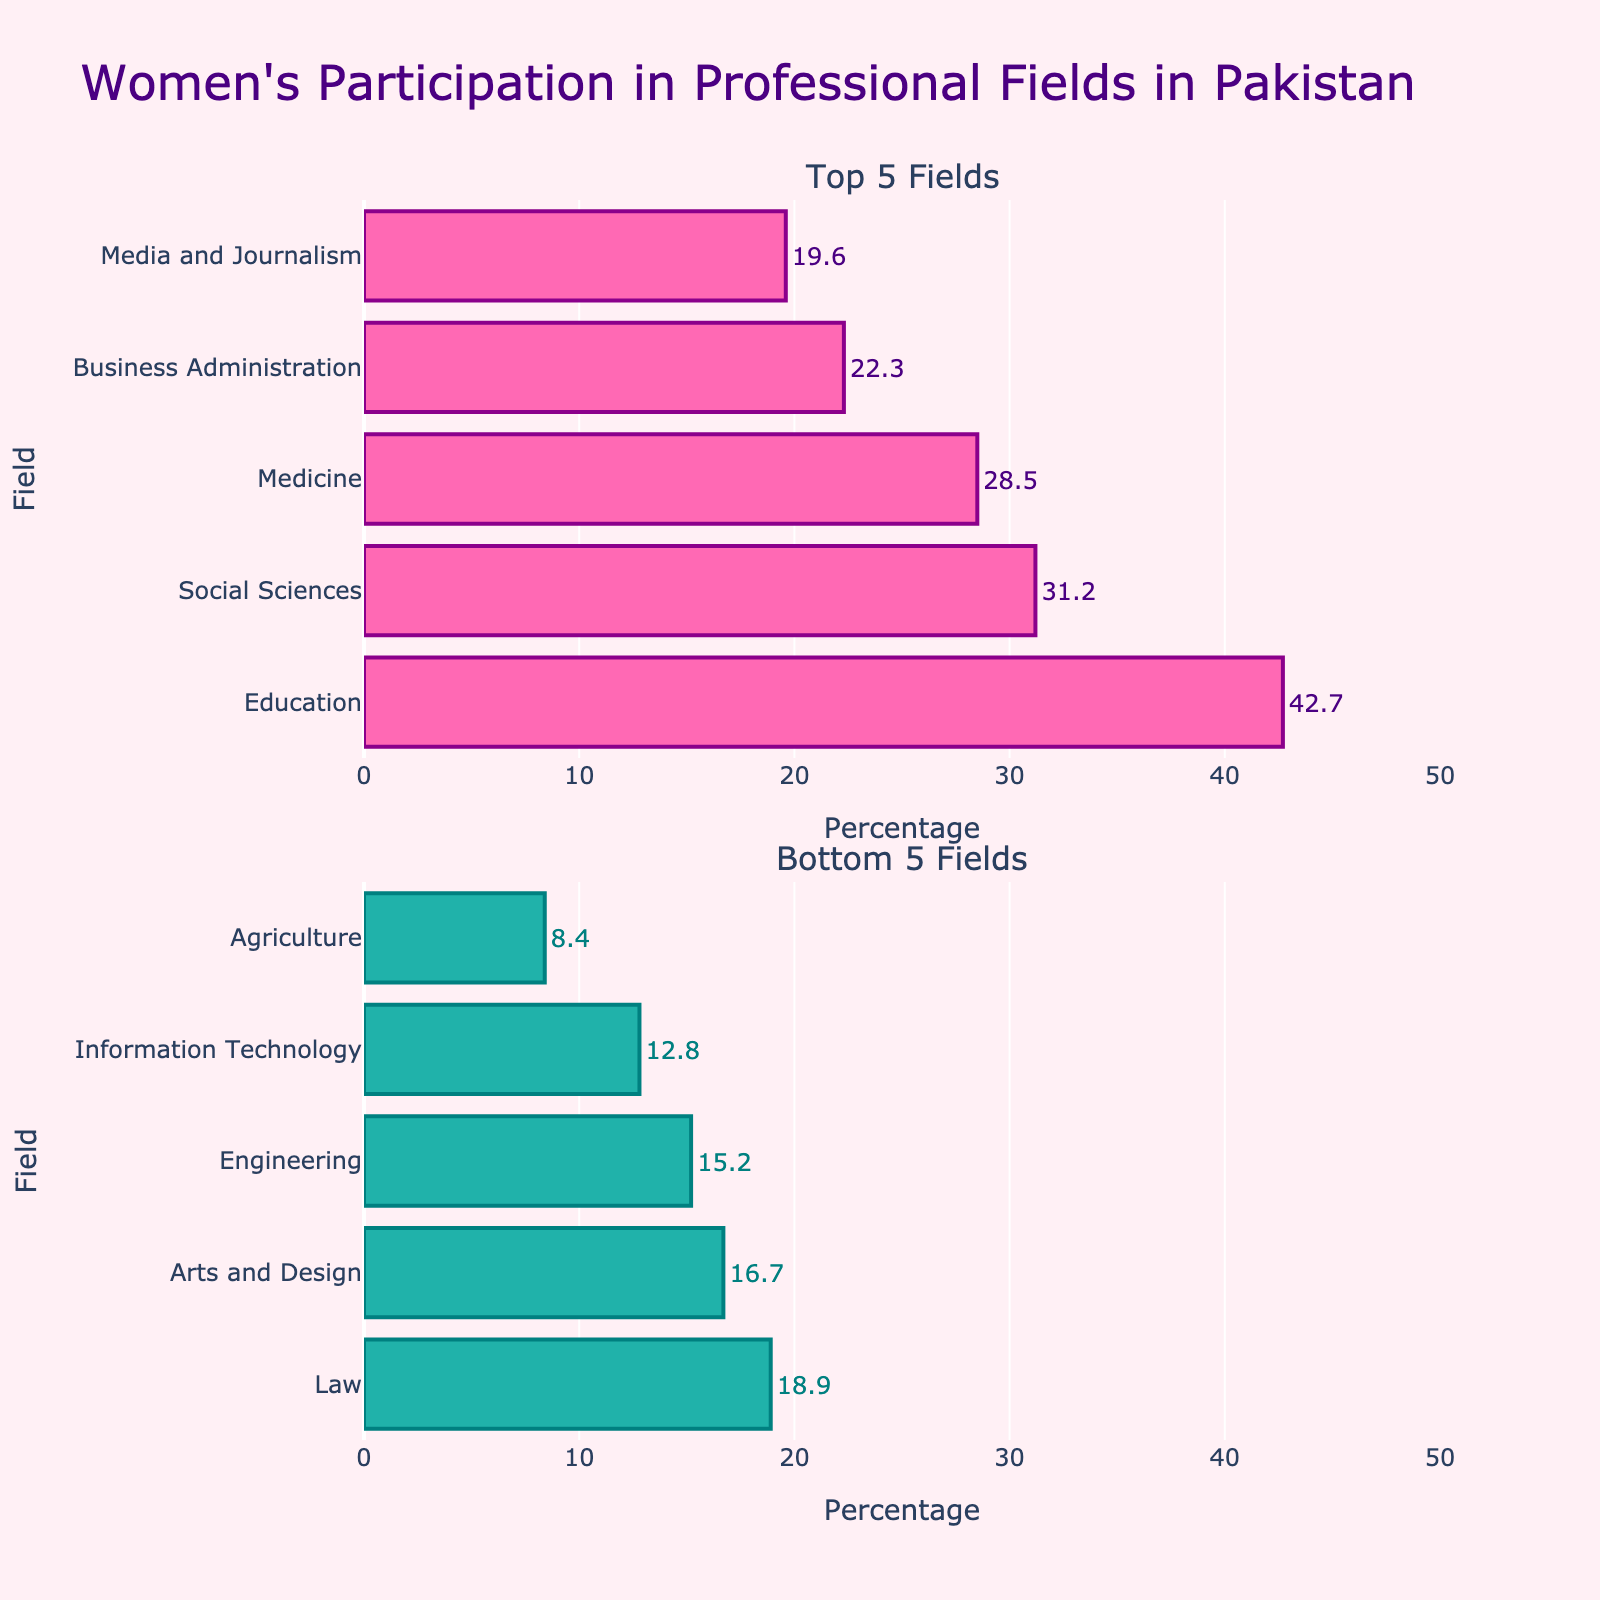Which bird species travels the longest distance? Look at the Distance Traveled by Bird Species plot, identify the bar with the greatest length; it's titled "Arctic Tern".
Answer: Arctic Tern How many days does the Sooty Shearwater take to migrate? Refer to the Migration Duration by Bird Species plot and find the duration bar for Sooty Shearwater, which shows 200 days.
Answer: 200 days Which species has the shortest migration duration? Check the Migration Duration by Bird Species plot. The shortest bar is for the American Golden Plover, with 3 days.
Answer: American Golden Plover What is the combined migration distance of the Bar-tailed Godwit and the Barn Swallow? Sum the distances from the Distance Traveled by Bird Species plot. Bar-tailed Godwit (11000 km) + Barn Swallow (11000 km) = 22000 km.
Answer: 22000 km By how many days does the migration duration of the Swainson's Hawk exceed that of the Ruby-throated Hummingbird? Subtract Ruby-throated Hummingbird's days from Swainson's Hawk's from the Migration Duration by Bird Species plot. 55 days - 21 days = 34 days.
Answer: 34 days Compare the migration distances of the Osprey and the Swainson’s Hawk. Which travels further and by how much? Find their distances in the Distance Traveled by Bird Species plot. Osprey (8000 km) and Swainson's Hawk (9000 km). Difference is 9000 km - 8000 km = 1000 km; Swainson's Hawk travels further.
Answer: Swainson's Hawk by 1000 km How does the duration of the Pectoral Sandpiper's migration compare with the Northern Wheatear's? Compare bars in Migration Duration by Bird Species plot. Pectoral Sandpiper (30 days) vs. Northern Wheatear (60 days). Pectoral Sandpiper's migration is shorter by 30 days.
Answer: 30 days shorter What is the average migration duration of all bird species in the figure? Sum all durations and divide by the number of species. Total is (90 + 8 + 21 + 40 + 50 + 3 + 200 + 60 + 30 + 55) = 557 days. Average is 557 days / 10 species = 55.7 days.
Answer: 55.7 days Which bird species have a migration distance greater than 10,000 kilometers? Check bars in the Distance Traveled by Bird Species plot above 10,000 km. Arctic Tern, Bar-tailed Godwit, Barn Swallow, Sooty Shearwater, and Northern Wheatear.
Answer: Arctic Tern, Bar-tailed Godwit, Barn Swallow, Sooty Shearwater, Northern Wheatear 